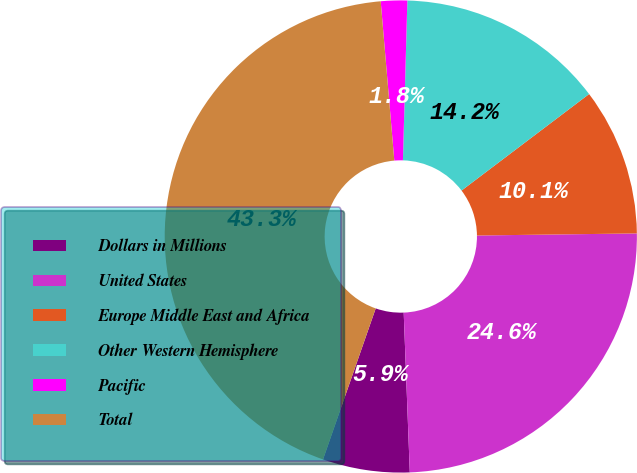Convert chart to OTSL. <chart><loc_0><loc_0><loc_500><loc_500><pie_chart><fcel>Dollars in Millions<fcel>United States<fcel>Europe Middle East and Africa<fcel>Other Western Hemisphere<fcel>Pacific<fcel>Total<nl><fcel>5.95%<fcel>24.6%<fcel>10.1%<fcel>14.25%<fcel>1.8%<fcel>43.3%<nl></chart> 